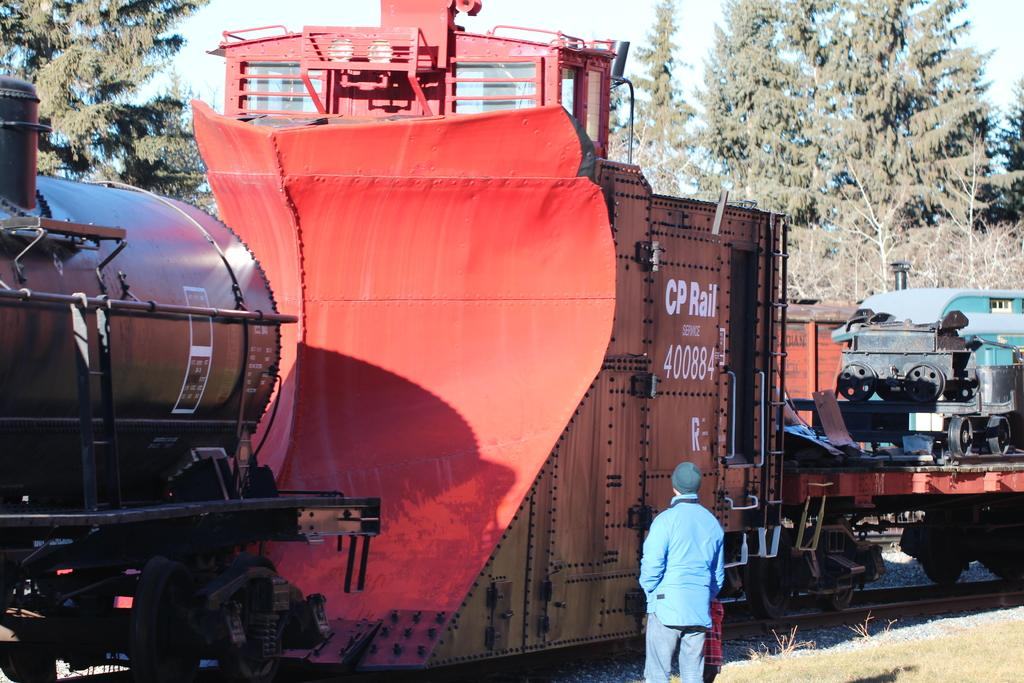What is the main subject in the image? There is a person standing in the image. What can be seen in the background of the image? There are trees and the sky visible in the background of the image. What is located on the track in the image? There is a train on a track in the image. What type of vegetation is present in the image? There is grass visible in the image. How does the person in the image care for the rest of the animals? There are no animals present in the image, so it is not possible to determine how the person cares for them. 